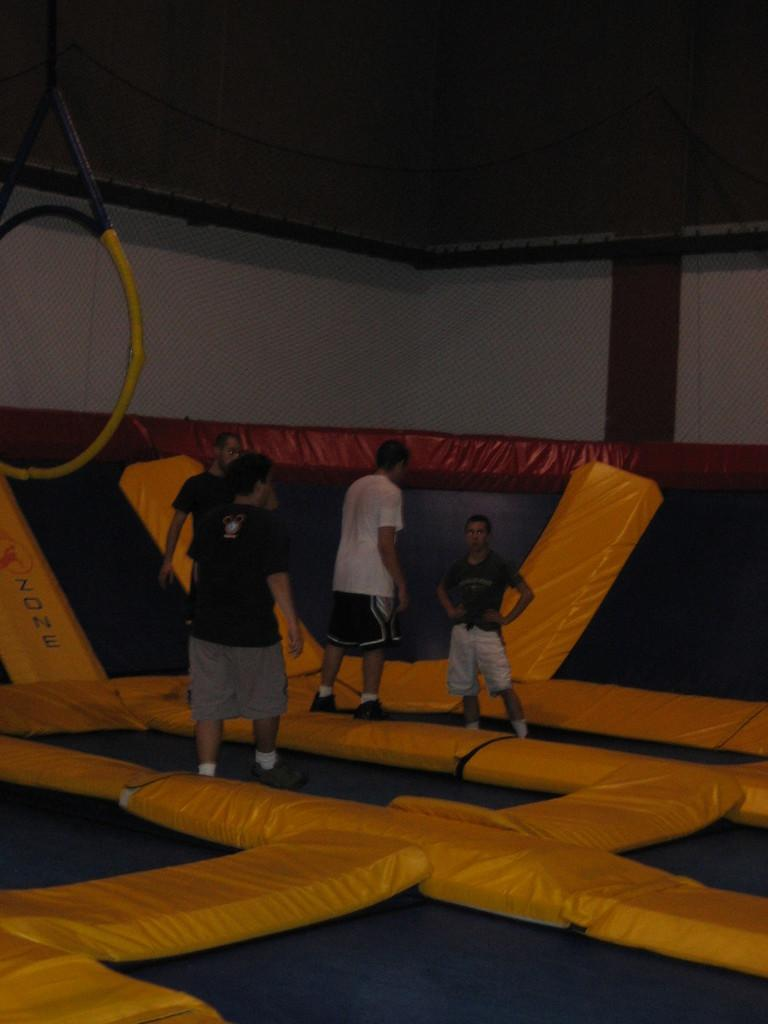What can be seen in the image involving multiple individuals? There is a group of people in the image. What are the people standing on? The people are standing on an object. What can be seen in the distance behind the group of people? There is a wall in the background of the image. What color are the objects in the background? There are yellow color objects in the background of the image. Is there smoke coming from the car in the image? There is no car present in the image, so it is not possible to determine if there is smoke coming from it. 